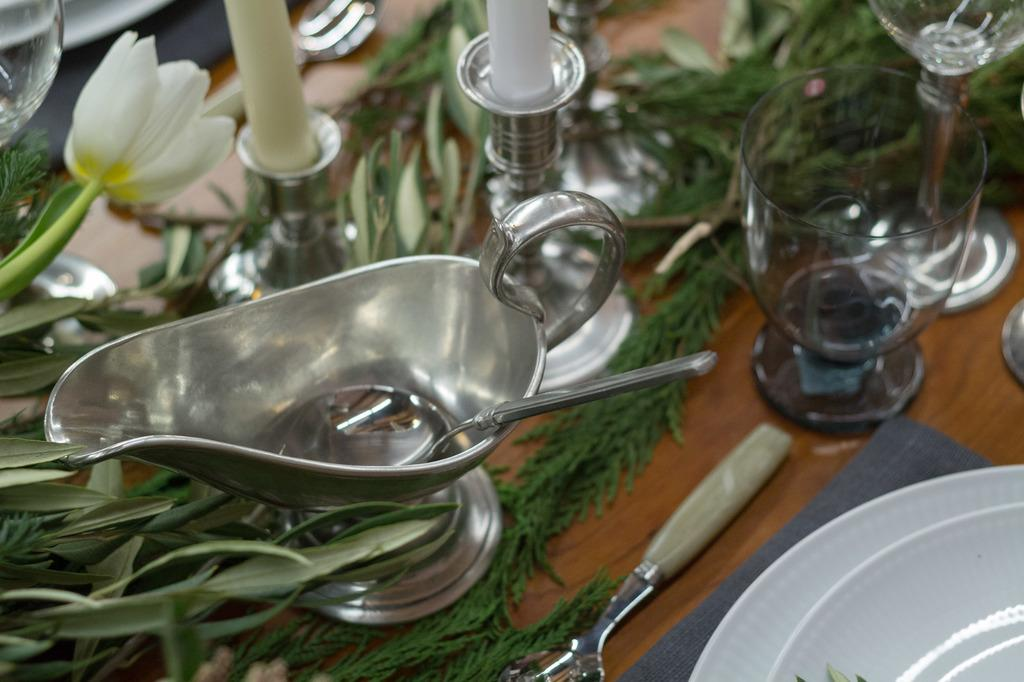What piece of furniture is present in the image? There is a table in the image. What is placed on the table? There is a glass, plates, a fork, and a spoon on the table. Can you describe the utensils on the table? There is a fork and a spoon on the table. Is there a squirrel painting on the canvas in the image? There is no canvas or squirrel painting present in the image. Can you touch the glass in the image? It is not possible to touch the glass in the image, as it is a two-dimensional representation. 